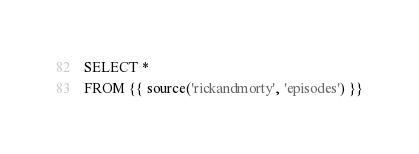<code> <loc_0><loc_0><loc_500><loc_500><_SQL_>SELECT *
FROM {{ source('rickandmorty', 'episodes') }}
</code> 